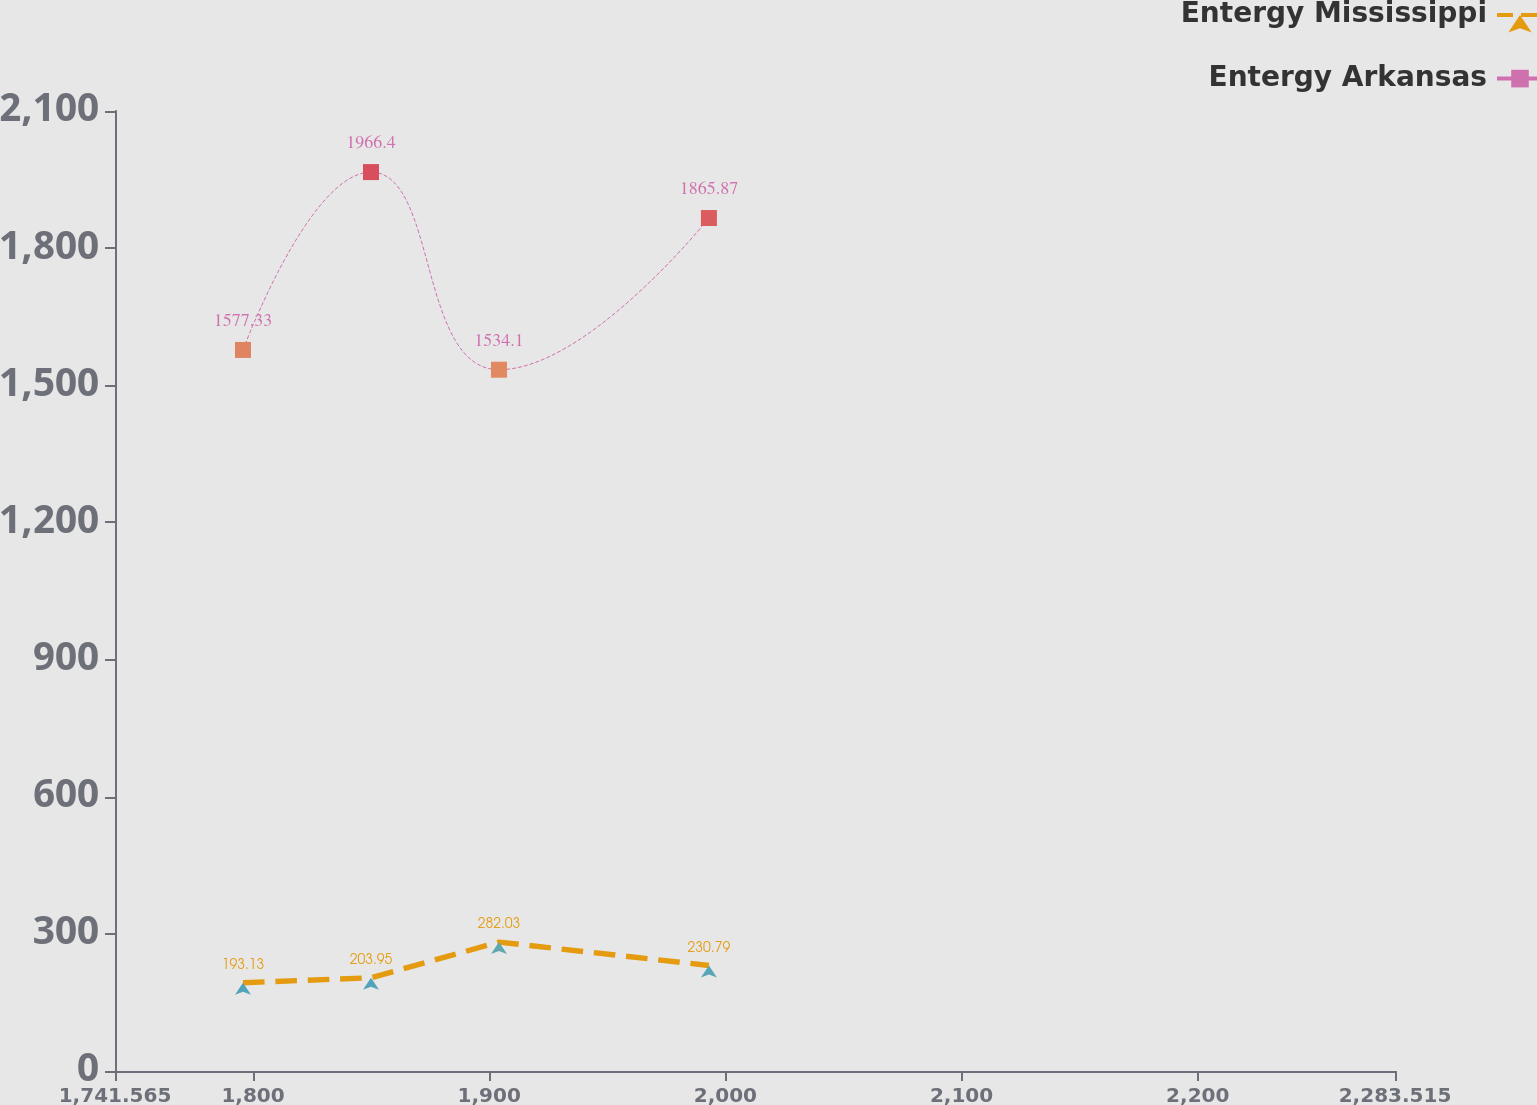Convert chart. <chart><loc_0><loc_0><loc_500><loc_500><line_chart><ecel><fcel>Entergy Mississippi<fcel>Entergy Arkansas<nl><fcel>1795.76<fcel>193.13<fcel>1577.33<nl><fcel>1849.95<fcel>203.95<fcel>1966.4<nl><fcel>1904.14<fcel>282.03<fcel>1534.1<nl><fcel>1993.03<fcel>230.79<fcel>1865.87<nl><fcel>2337.71<fcel>273.23<fcel>1909.1<nl></chart> 